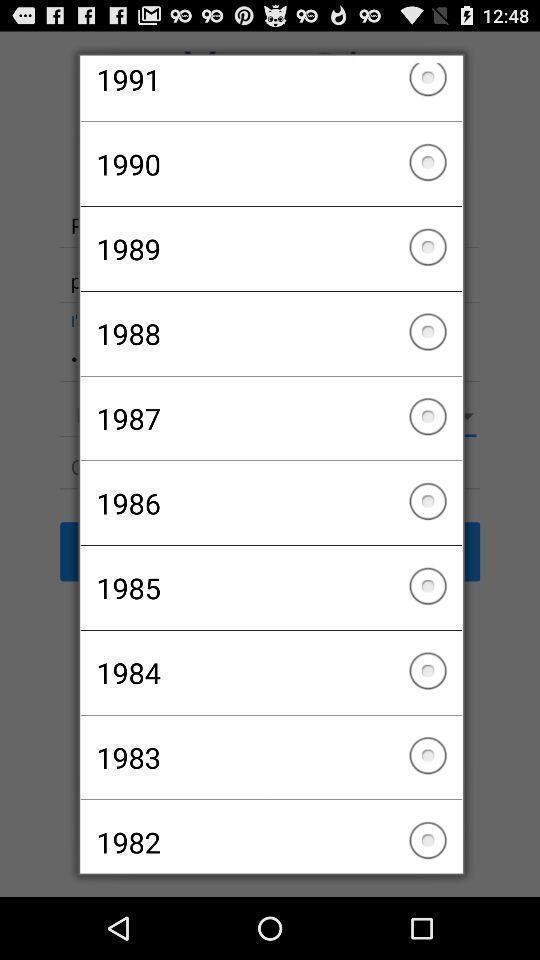Tell me about the visual elements in this screen capture. Pop-up to choose a year. 